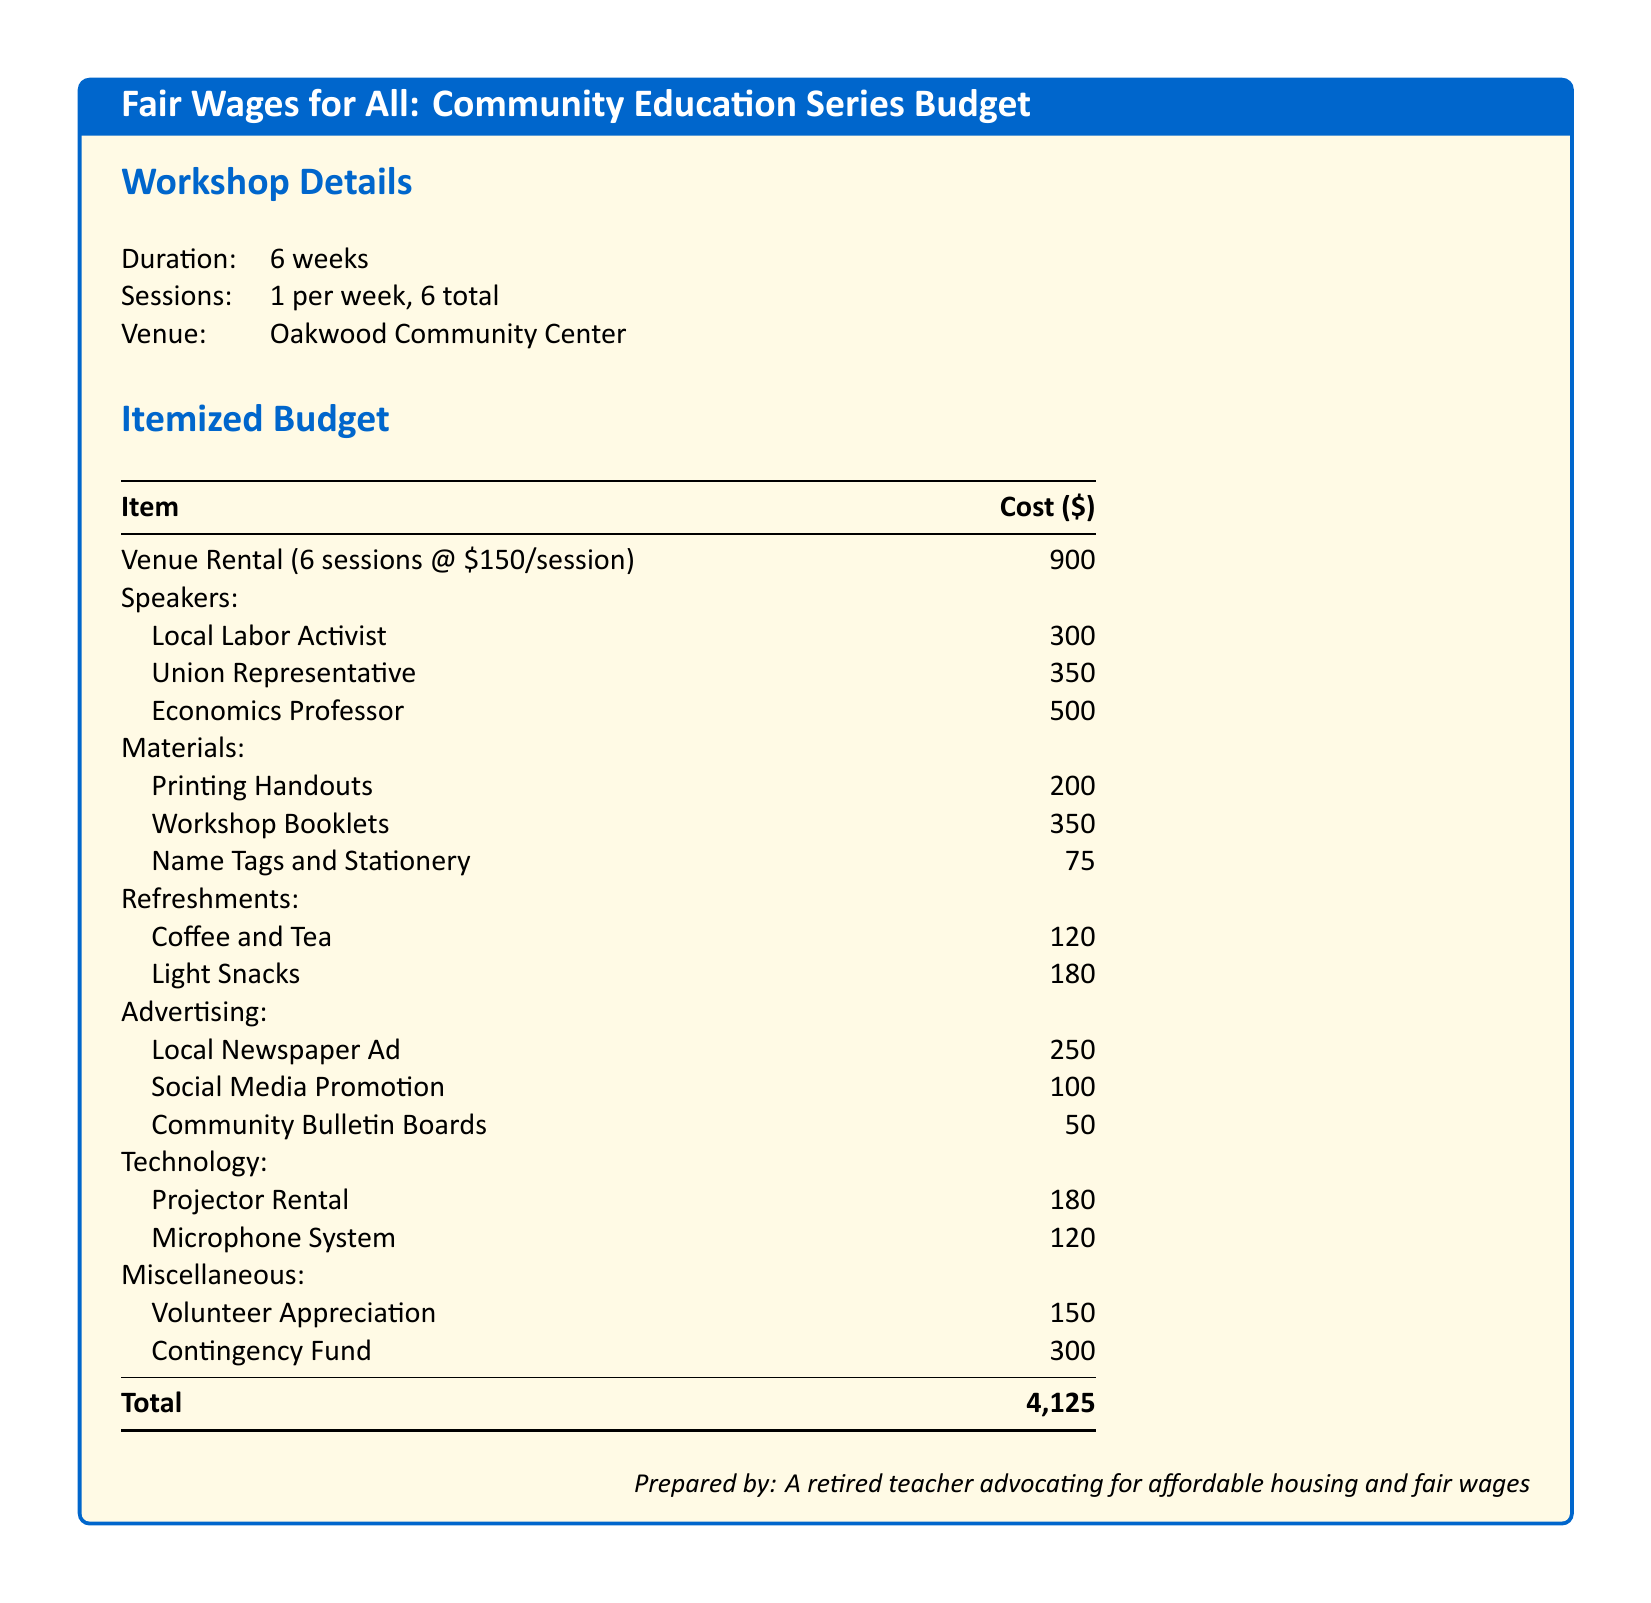What is the total cost of the workshop series? The total cost is provided at the bottom of the budget table, which sums all individual line items.
Answer: 4,125 How many sessions will there be? The number of sessions is specified under the workshop details section, indicating how many workshops will occur over the duration.
Answer: 6 total What is the cost for the venue rental? Venue rental cost is broken down in the itemized budget, showing how much will be spent for renting the community center across all sessions.
Answer: 900 Who is one of the speakers listed? The budget includes several individual speakers under the speakers section, each of whom will be contributing to the workshop.
Answer: Local Labor Activist How much is allocated for refreshments? The budget includes a specific subsection for refreshments, detailing the cost contributions for different food and beverage items provided at the workshop.
Answer: 300 What is the cost of the contingency fund? The contingency fund is explicitly itemized in the budget to prepare for any unforeseen expenses that may arise during the project.
Answer: 300 What venue is hosting the workshops? The specific venue for the workshops is mentioned in the workshop details section, providing clarity on the location of the events.
Answer: Oakwood Community Center How much will be spent on advertising? The budget outlines the total cost dedicated to different advertising methods to promote the workshop, which contributes to overall expenses.
Answer: 400 What is the cost of printing handouts? This cost is itemized in the materials section, indicating how much will be spent on providing informational materials to participants.
Answer: 200 How many weeks will the workshop series run? The duration of the workshop is stated in the workshop details section, clarifying the period over which the series will be conducted.
Answer: 6 weeks 